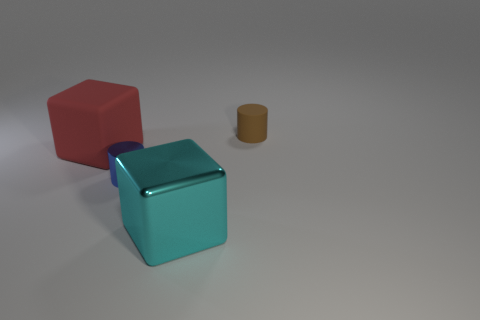Add 3 big yellow blocks. How many objects exist? 7 Add 4 cyan shiny cubes. How many cyan shiny cubes are left? 5 Add 3 blue shiny spheres. How many blue shiny spheres exist? 3 Subtract 0 gray cubes. How many objects are left? 4 Subtract all tiny blue cubes. Subtract all blue metallic things. How many objects are left? 3 